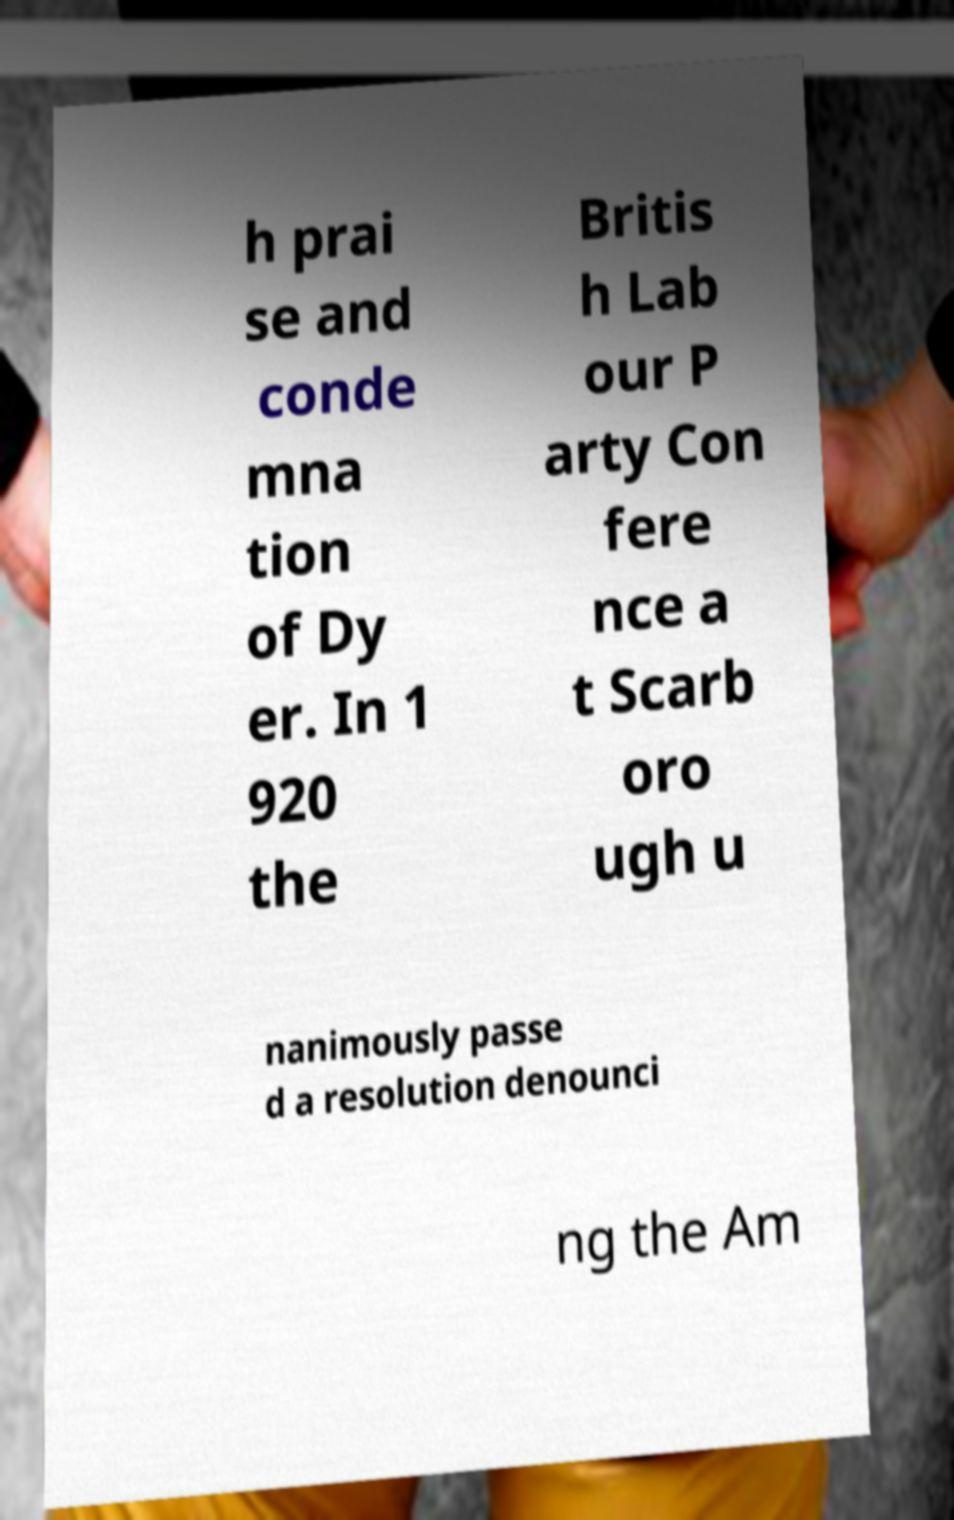Could you extract and type out the text from this image? h prai se and conde mna tion of Dy er. In 1 920 the Britis h Lab our P arty Con fere nce a t Scarb oro ugh u nanimously passe d a resolution denounci ng the Am 